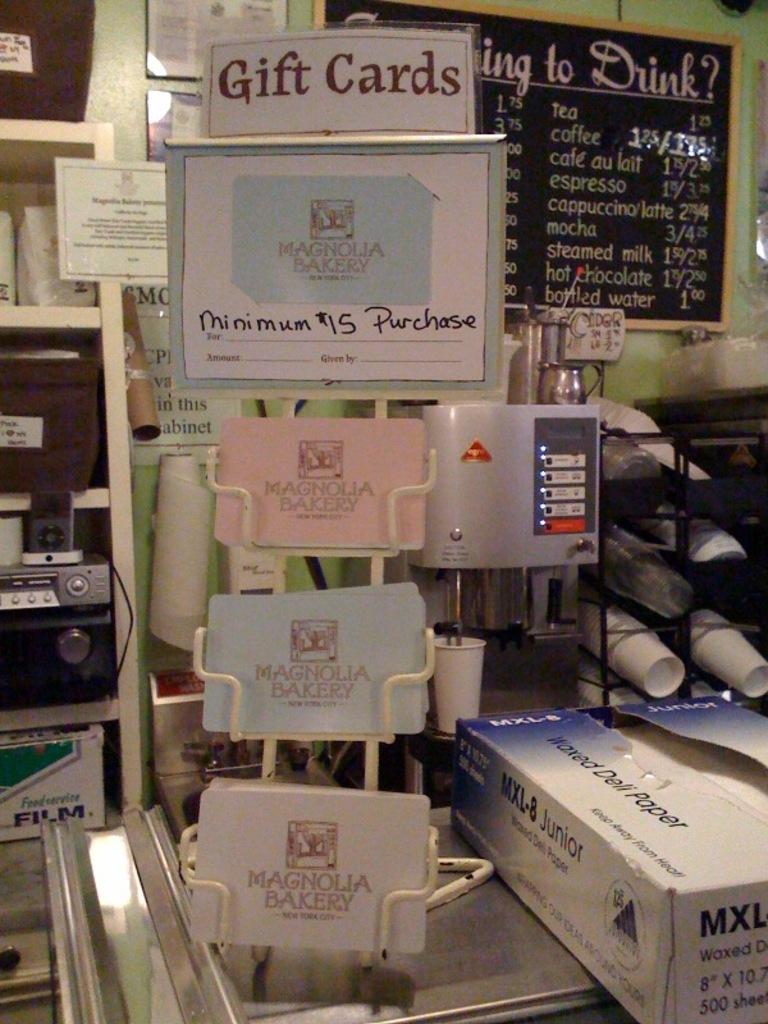<image>
Describe the image concisely. A display for Magnolia Bakery giftcards citing a $15 minimum purchase. 